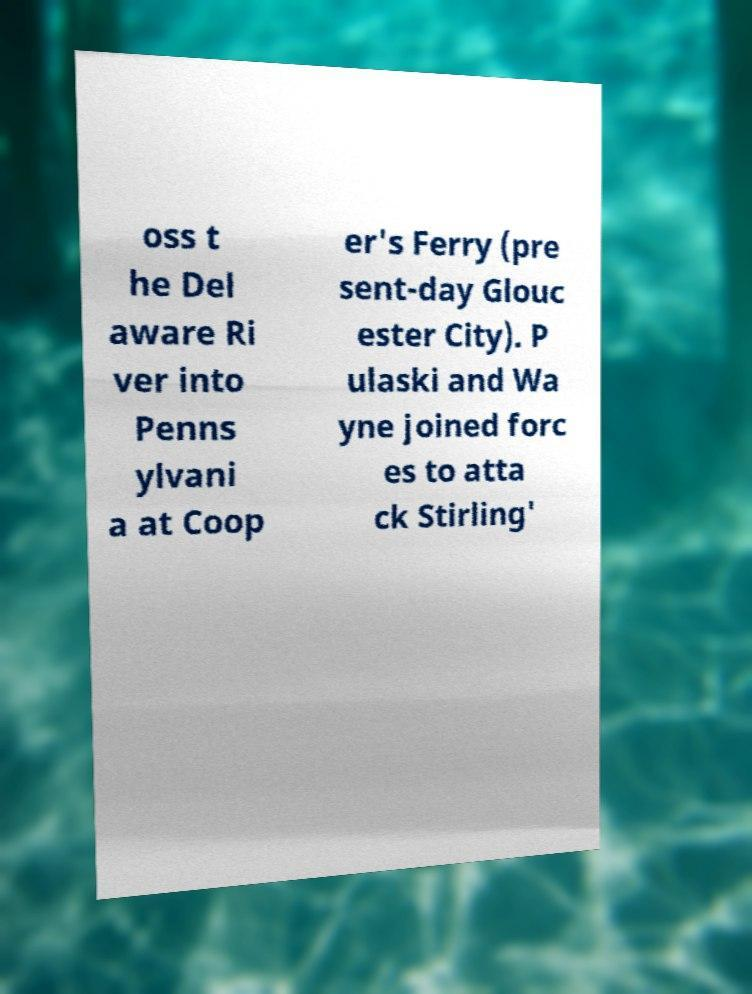I need the written content from this picture converted into text. Can you do that? oss t he Del aware Ri ver into Penns ylvani a at Coop er's Ferry (pre sent-day Glouc ester City). P ulaski and Wa yne joined forc es to atta ck Stirling' 